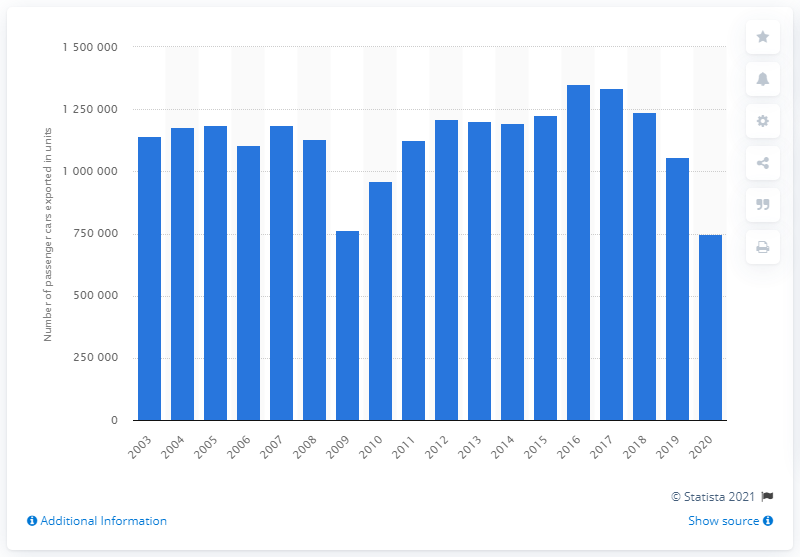List a handful of essential elements in this visual. In 2016, a total of 134,944,300 vehicles were exported from the United Kingdom. 